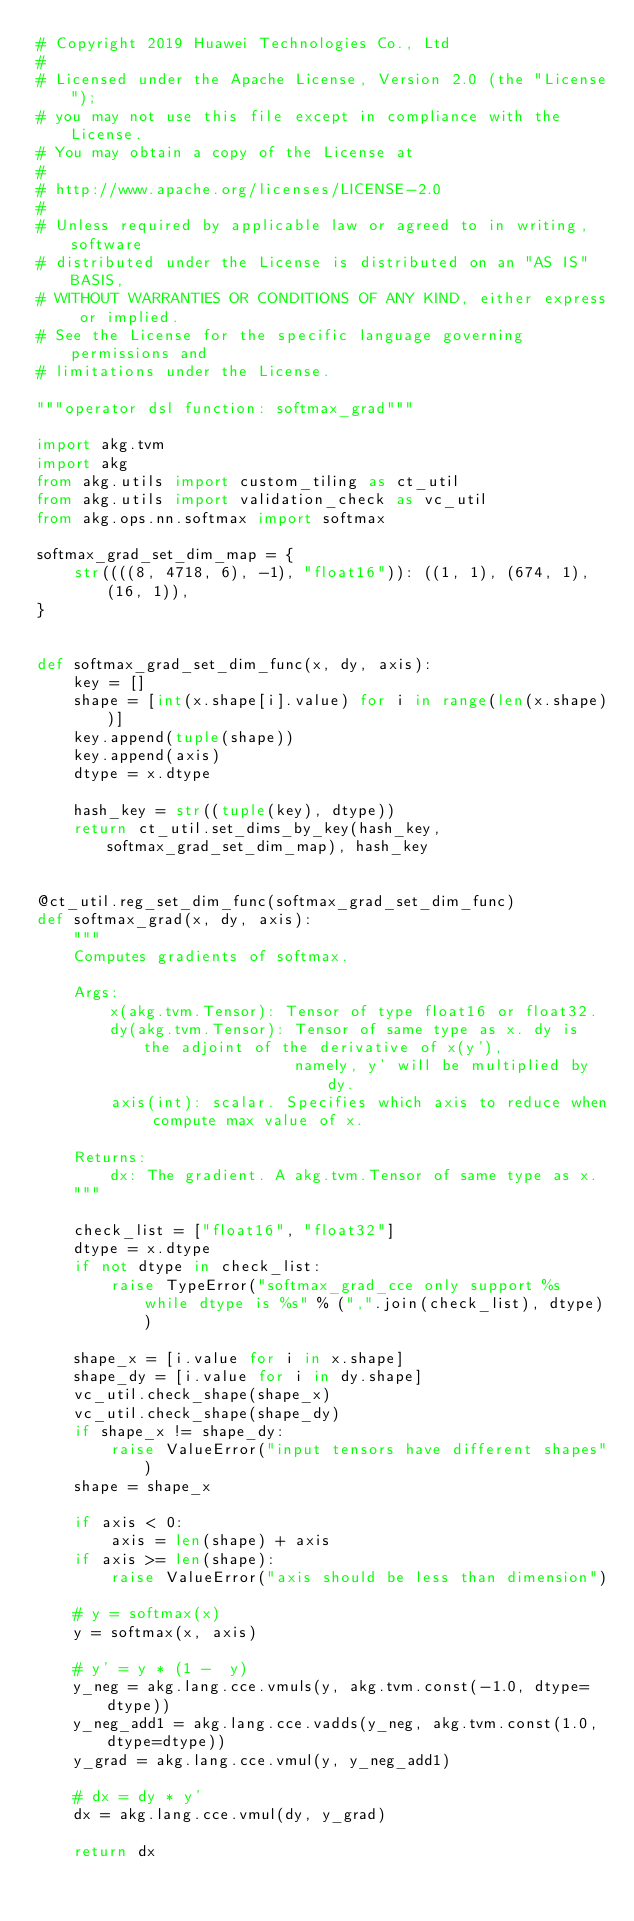Convert code to text. <code><loc_0><loc_0><loc_500><loc_500><_Python_># Copyright 2019 Huawei Technologies Co., Ltd
#
# Licensed under the Apache License, Version 2.0 (the "License");
# you may not use this file except in compliance with the License.
# You may obtain a copy of the License at
#
# http://www.apache.org/licenses/LICENSE-2.0
#
# Unless required by applicable law or agreed to in writing, software
# distributed under the License is distributed on an "AS IS" BASIS,
# WITHOUT WARRANTIES OR CONDITIONS OF ANY KIND, either express or implied.
# See the License for the specific language governing permissions and
# limitations under the License.

"""operator dsl function: softmax_grad"""

import akg.tvm
import akg
from akg.utils import custom_tiling as ct_util
from akg.utils import validation_check as vc_util
from akg.ops.nn.softmax import softmax

softmax_grad_set_dim_map = {
    str((((8, 4718, 6), -1), "float16")): ((1, 1), (674, 1), (16, 1)),
}


def softmax_grad_set_dim_func(x, dy, axis):
    key = []
    shape = [int(x.shape[i].value) for i in range(len(x.shape))]
    key.append(tuple(shape))
    key.append(axis)
    dtype = x.dtype

    hash_key = str((tuple(key), dtype))
    return ct_util.set_dims_by_key(hash_key, softmax_grad_set_dim_map), hash_key


@ct_util.reg_set_dim_func(softmax_grad_set_dim_func)
def softmax_grad(x, dy, axis):
    """
    Computes gradients of softmax.

    Args:
        x(akg.tvm.Tensor): Tensor of type float16 or float32.
        dy(akg.tvm.Tensor): Tensor of same type as x. dy is the adjoint of the derivative of x(y'),
                            namely, y' will be multiplied by dy.
        axis(int): scalar. Specifies which axis to reduce when compute max value of x.

    Returns:
        dx: The gradient. A akg.tvm.Tensor of same type as x.
    """

    check_list = ["float16", "float32"]
    dtype = x.dtype
    if not dtype in check_list:
        raise TypeError("softmax_grad_cce only support %s while dtype is %s" % (",".join(check_list), dtype))

    shape_x = [i.value for i in x.shape]
    shape_dy = [i.value for i in dy.shape]
    vc_util.check_shape(shape_x)
    vc_util.check_shape(shape_dy)
    if shape_x != shape_dy:
        raise ValueError("input tensors have different shapes")
    shape = shape_x

    if axis < 0:
        axis = len(shape) + axis
    if axis >= len(shape):
        raise ValueError("axis should be less than dimension")

    # y = softmax(x)
    y = softmax(x, axis)

    # y' = y * (1 -  y)
    y_neg = akg.lang.cce.vmuls(y, akg.tvm.const(-1.0, dtype=dtype))
    y_neg_add1 = akg.lang.cce.vadds(y_neg, akg.tvm.const(1.0, dtype=dtype))
    y_grad = akg.lang.cce.vmul(y, y_neg_add1)

    # dx = dy * y'
    dx = akg.lang.cce.vmul(dy, y_grad)

    return dx
</code> 